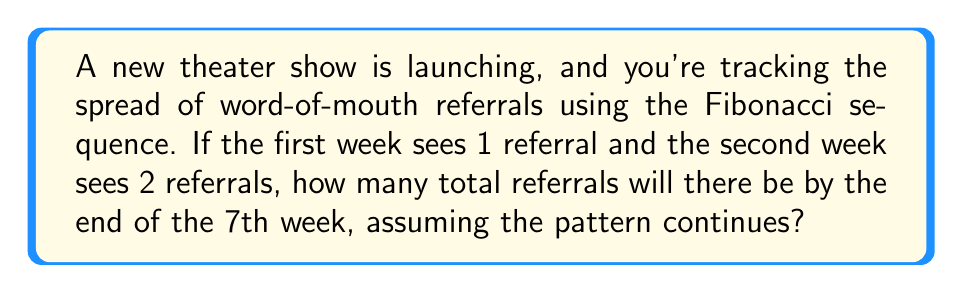Solve this math problem. Let's approach this step-by-step:

1) The Fibonacci sequence starts with 1, 1, and then each subsequent number is the sum of the two preceding ones.

2) Given:
   Week 1: 1 referral
   Week 2: 2 referrals

3) Let's calculate the referrals for each week:
   Week 1: 1
   Week 2: 2
   Week 3: 1 + 2 = 3
   Week 4: 2 + 3 = 5
   Week 5: 3 + 5 = 8
   Week 6: 5 + 8 = 13
   Week 7: 8 + 13 = 21

4) The sequence is: 1, 2, 3, 5, 8, 13, 21

5) To find the total referrals, we sum all these numbers:

   $$ \text{Total} = 1 + 2 + 3 + 5 + 8 + 13 + 21 = 53 $$

Therefore, by the end of the 7th week, there will be a total of 53 referrals.
Answer: 53 referrals 